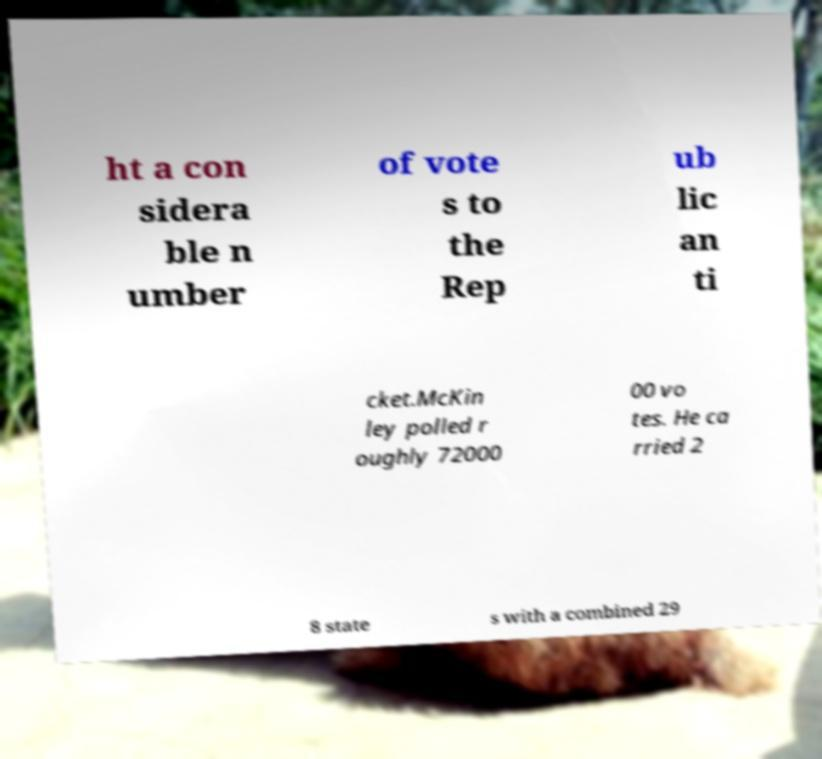Could you extract and type out the text from this image? ht a con sidera ble n umber of vote s to the Rep ub lic an ti cket.McKin ley polled r oughly 72000 00 vo tes. He ca rried 2 8 state s with a combined 29 